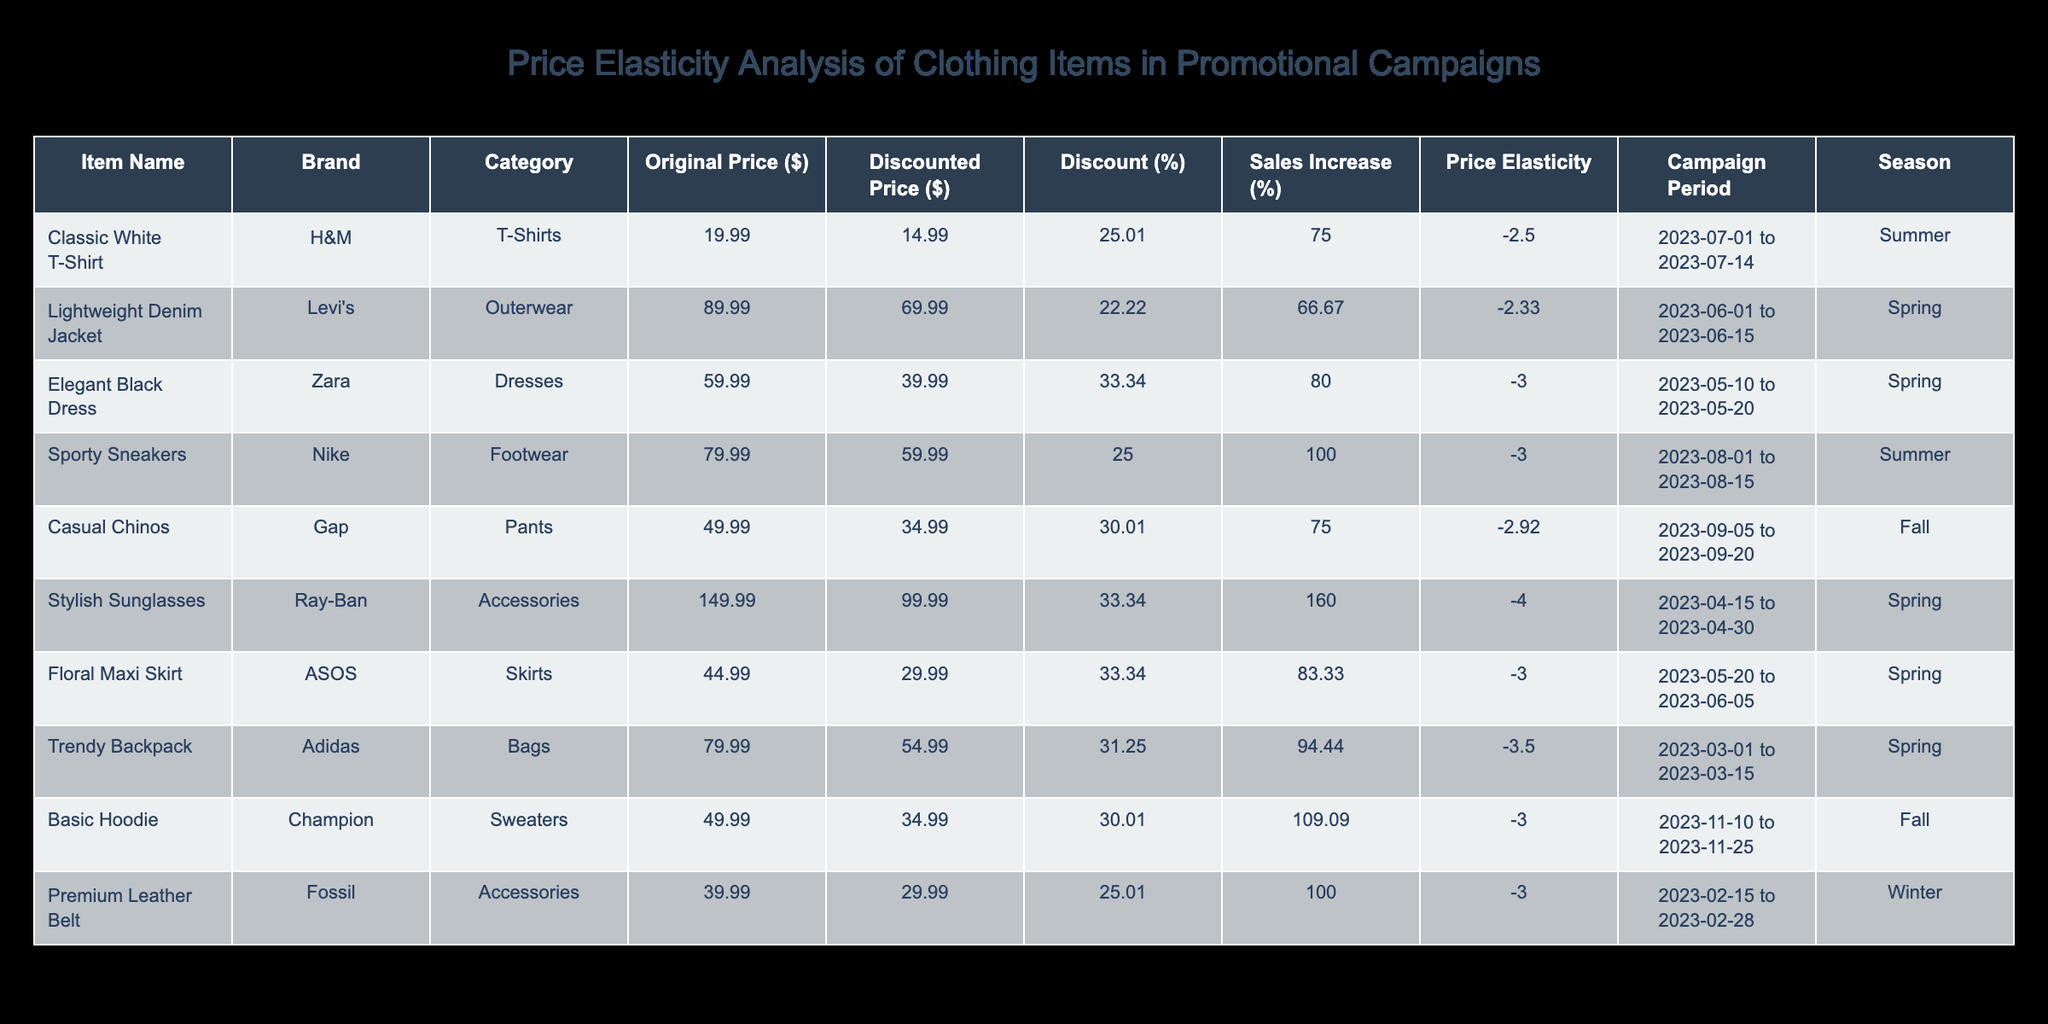What is the discounted price of the Classic White T-Shirt? The discounted price for the Classic White T-Shirt is provided in the corresponding column of the table. It reads $14.99.
Answer: 14.99 Which item shows the highest price elasticity? The table indicates price elasticity in the respective column. The Stylish Sunglasses have the highest value at -4.00, which is more elastic compared to other items.
Answer: -4.00 Is the sales volume after the promotion higher for the Floral Maxi Skirt compared to the Sporty Sneakers? The table lists the sales volume after promotion for the Floral Maxi Skirt as 110 and for the Sporty Sneakers as 160. Since 110 is less than 160, the answer is no.
Answer: No What is the average sales increase percentage across all items? First, we list the sales increase percentages from the table: 75.00 (Classic White T-Shirt), 66.67 (Lightweight Denim Jacket), 80.00 (Elegant Black Dress), 100.00 (Sporty Sneakers), 75.00 (Casual Chinos), 160.00 (Stylish Sunglasses), 83.33 (Floral Maxi Skirt), 94.44 (Trendy Backpack), 109.09 (Basic Hoodie), and 100.00 (Premium Leather Belt). Adding these values gives 1010.00, and dividing by 10 results in an average of 101.00.
Answer: 101.00 Did the Casual Chinos experience a greater increase in sales volume compared to the Elegant Black Dress? The sales volume increase for Casual Chinos is 75, while the Elegant Black Dress saw an increase of 80. Since 75 is less than 80, the answer is no.
Answer: No What is the discount percentage for the Organic Premium Leather Belt? The price discount percentage can be calculated using the formula \(((Original Price - Discounted Price) / Original Price) * 100\). For the Premium Leather Belt: \(((39.99 - 29.99) / 39.99) * 100 = 25.01\). So, the discount percentage is approximately 25.01%.
Answer: 25.01 Which brand has the most items with a price elasticity value more negative than -3.00? By reviewing the elasticity values, H&M, Zara, Nike, Gap, ASOS, and Champion all have items with elasticity values below -3.00. Count the items for each brand: H&M (1), Zara (1), Nike (1), Gap (1), ASOS (1), and Champion (1). Each brand has one item, making it equal. Therefore, no brand distinctly has more items.
Answer: None What are the total sales volumes (before and after promotions) for the Fashion Accessories category? For Accessories, the original sales volumes are: Stylish Sunglasses (50 before, 130 after) and Premium Leather Belt (45 before, 90 after). Therefore, total sales volume before equals 50 + 45 = 95 and total after equals 130 + 90 = 220.
Answer: Before: 95, After: 220 